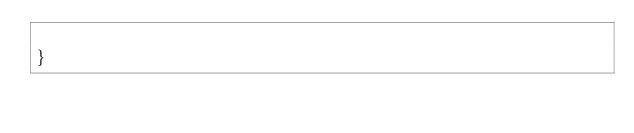<code> <loc_0><loc_0><loc_500><loc_500><_PHP_>
}</code> 